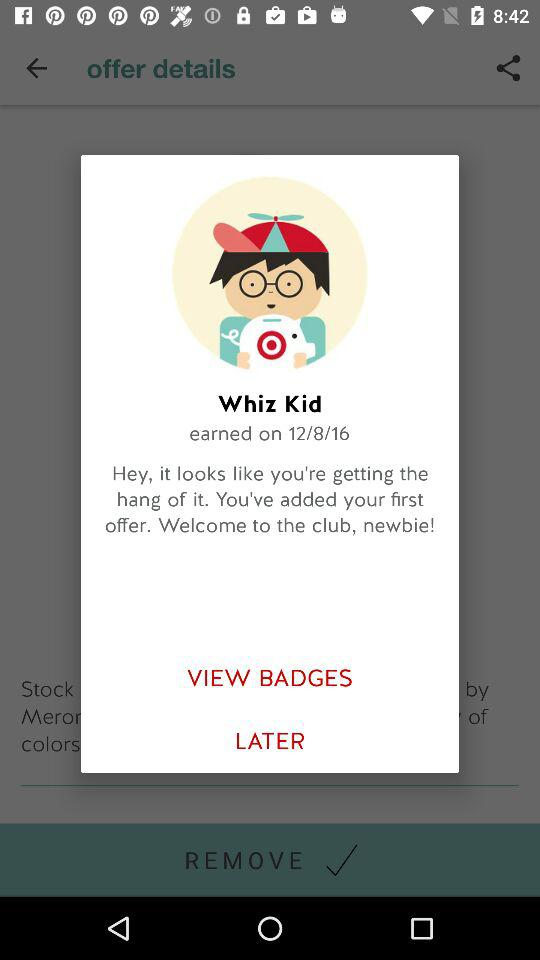What is the offer name?
When the provided information is insufficient, respond with <no answer>. <no answer> 